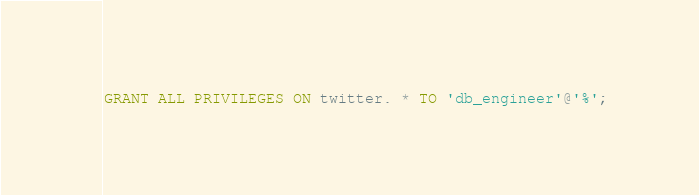Convert code to text. <code><loc_0><loc_0><loc_500><loc_500><_SQL_>GRANT ALL PRIVILEGES ON twitter. * TO 'db_engineer'@'%';</code> 